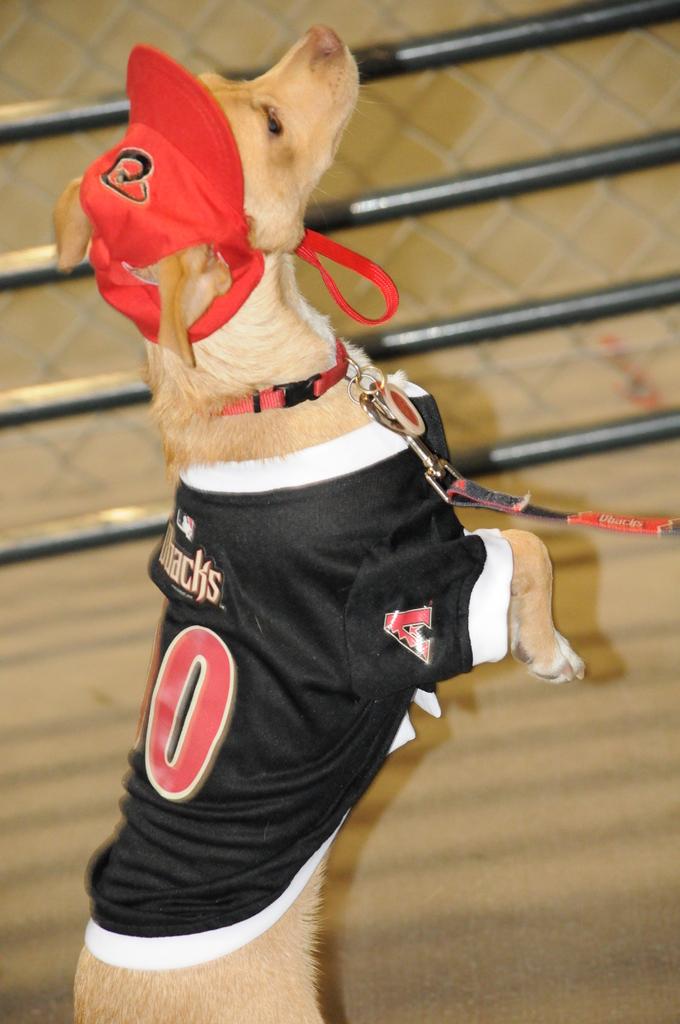What letter is on the sleeve?
Your answer should be very brief. A. 